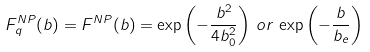Convert formula to latex. <formula><loc_0><loc_0><loc_500><loc_500>F _ { q } ^ { N P } ( b ) = F ^ { N P } ( b ) = \exp \left ( - \frac { b ^ { 2 } } { 4 b _ { 0 } ^ { 2 } } \right ) \, o r \, \exp \left ( - \frac { b } { b _ { e } } \right )</formula> 